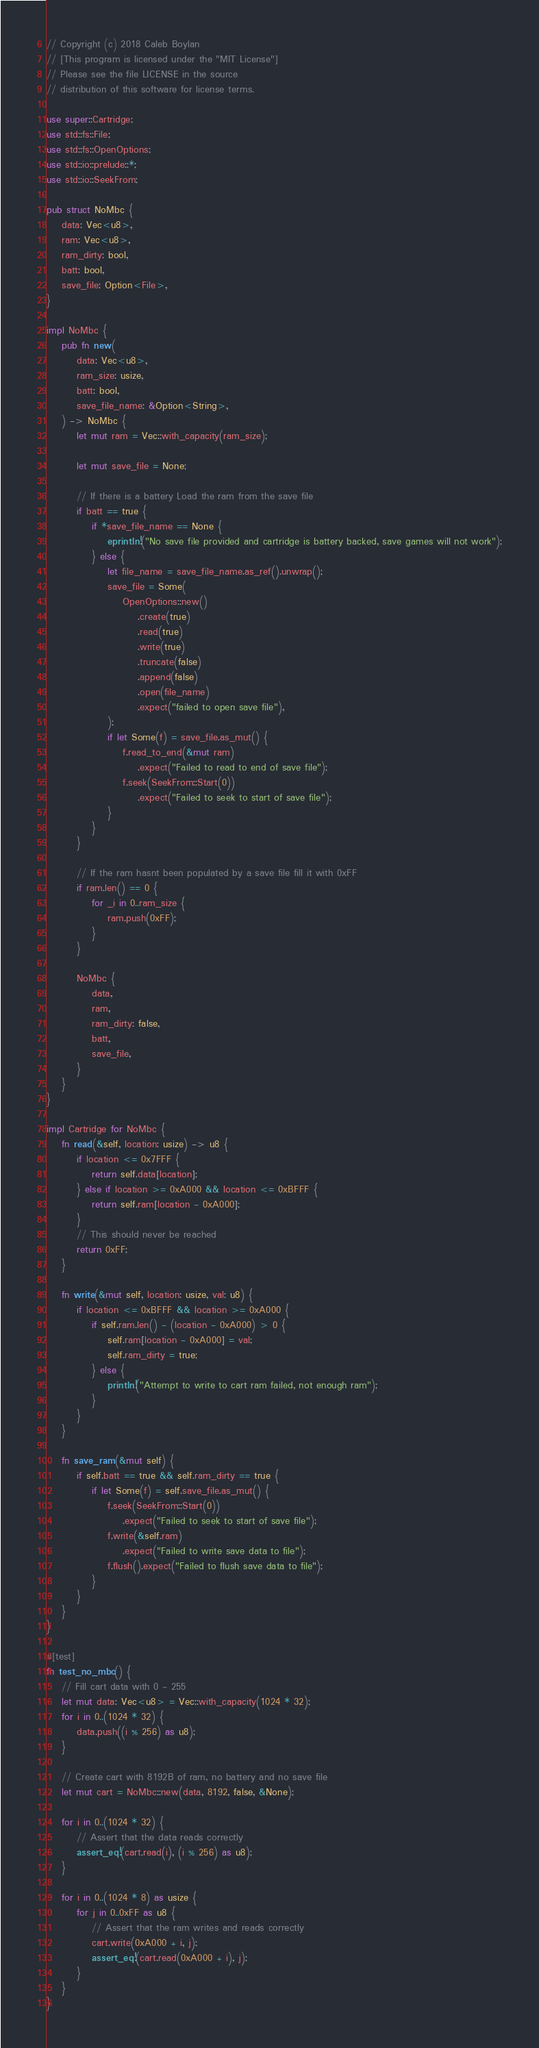Convert code to text. <code><loc_0><loc_0><loc_500><loc_500><_Rust_>// Copyright (c) 2018 Caleb Boylan
// [This program is licensed under the "MIT License"]
// Please see the file LICENSE in the source
// distribution of this software for license terms.

use super::Cartridge;
use std::fs::File;
use std::fs::OpenOptions;
use std::io::prelude::*;
use std::io::SeekFrom;

pub struct NoMbc {
    data: Vec<u8>,
    ram: Vec<u8>,
    ram_dirty: bool,
    batt: bool,
    save_file: Option<File>,
}

impl NoMbc {
    pub fn new(
        data: Vec<u8>,
        ram_size: usize,
        batt: bool,
        save_file_name: &Option<String>,
    ) -> NoMbc {
        let mut ram = Vec::with_capacity(ram_size);

        let mut save_file = None;

        // If there is a battery Load the ram from the save file
        if batt == true {
            if *save_file_name == None {
                eprintln!("No save file provided and cartridge is battery backed, save games will not work");
            } else {
                let file_name = save_file_name.as_ref().unwrap();
                save_file = Some(
                    OpenOptions::new()
                        .create(true)
                        .read(true)
                        .write(true)
                        .truncate(false)
                        .append(false)
                        .open(file_name)
                        .expect("failed to open save file"),
                );
                if let Some(f) = save_file.as_mut() {
                    f.read_to_end(&mut ram)
                        .expect("Failed to read to end of save file");
                    f.seek(SeekFrom::Start(0))
                        .expect("Failed to seek to start of save file");
                }
            }
        }

        // If the ram hasnt been populated by a save file fill it with 0xFF
        if ram.len() == 0 {
            for _i in 0..ram_size {
                ram.push(0xFF);
            }
        }

        NoMbc {
            data,
            ram,
            ram_dirty: false,
            batt,
            save_file,
        }
    }
}

impl Cartridge for NoMbc {
    fn read(&self, location: usize) -> u8 {
        if location <= 0x7FFF {
            return self.data[location];
        } else if location >= 0xA000 && location <= 0xBFFF {
            return self.ram[location - 0xA000];
        }
        // This should never be reached
        return 0xFF;
    }

    fn write(&mut self, location: usize, val: u8) {
        if location <= 0xBFFF && location >= 0xA000 {
            if self.ram.len() - (location - 0xA000) > 0 {
                self.ram[location - 0xA000] = val;
                self.ram_dirty = true;
            } else {
                println!("Attempt to write to cart ram failed, not enough ram");
            }
        }
    }

    fn save_ram(&mut self) {
        if self.batt == true && self.ram_dirty == true {
            if let Some(f) = self.save_file.as_mut() {
                f.seek(SeekFrom::Start(0))
                    .expect("Failed to seek to start of save file");
                f.write(&self.ram)
                    .expect("Failed to write save data to file");
                f.flush().expect("Failed to flush save data to file");
            }
        }
    }
}

#[test]
fn test_no_mbc() {
    // Fill cart data with 0 - 255
    let mut data: Vec<u8> = Vec::with_capacity(1024 * 32);
    for i in 0..(1024 * 32) {
        data.push((i % 256) as u8);
    }

    // Create cart with 8192B of ram, no battery and no save file
    let mut cart = NoMbc::new(data, 8192, false, &None);

    for i in 0..(1024 * 32) {
        // Assert that the data reads correctly
        assert_eq!(cart.read(i), (i % 256) as u8);
    }

    for i in 0..(1024 * 8) as usize {
        for j in 0..0xFF as u8 {
            // Assert that the ram writes and reads correctly
            cart.write(0xA000 + i, j);
            assert_eq!(cart.read(0xA000 + i), j);
        }
    }
}
</code> 